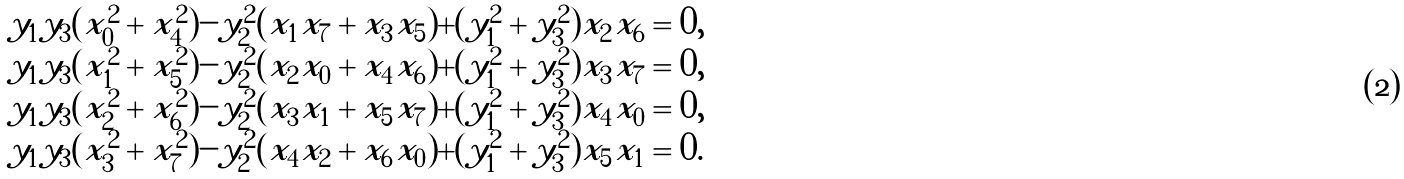Convert formula to latex. <formula><loc_0><loc_0><loc_500><loc_500>\begin{array} { l } y _ { 1 } y _ { 3 } ( x _ { 0 } ^ { 2 } + x _ { 4 } ^ { 2 } ) - y _ { 2 } ^ { 2 } ( x _ { 1 } x _ { 7 } + x _ { 3 } x _ { 5 } ) + ( y _ { 1 } ^ { 2 } + y _ { 3 } ^ { 2 } ) x _ { 2 } x _ { 6 } = 0 , \\ y _ { 1 } y _ { 3 } ( x _ { 1 } ^ { 2 } + x _ { 5 } ^ { 2 } ) - y _ { 2 } ^ { 2 } ( x _ { 2 } x _ { 0 } + x _ { 4 } x _ { 6 } ) + ( y _ { 1 } ^ { 2 } + y _ { 3 } ^ { 2 } ) x _ { 3 } x _ { 7 } = 0 , \\ y _ { 1 } y _ { 3 } ( x _ { 2 } ^ { 2 } + x _ { 6 } ^ { 2 } ) - y _ { 2 } ^ { 2 } ( x _ { 3 } x _ { 1 } + x _ { 5 } x _ { 7 } ) + ( y _ { 1 } ^ { 2 } + y _ { 3 } ^ { 2 } ) x _ { 4 } x _ { 0 } = 0 , \\ y _ { 1 } y _ { 3 } ( x _ { 3 } ^ { 2 } + x _ { 7 } ^ { 2 } ) - y _ { 2 } ^ { 2 } ( x _ { 4 } x _ { 2 } + x _ { 6 } x _ { 0 } ) + ( y _ { 1 } ^ { 2 } + y _ { 3 } ^ { 2 } ) x _ { 5 } x _ { 1 } = 0 . \\ \end{array}</formula> 